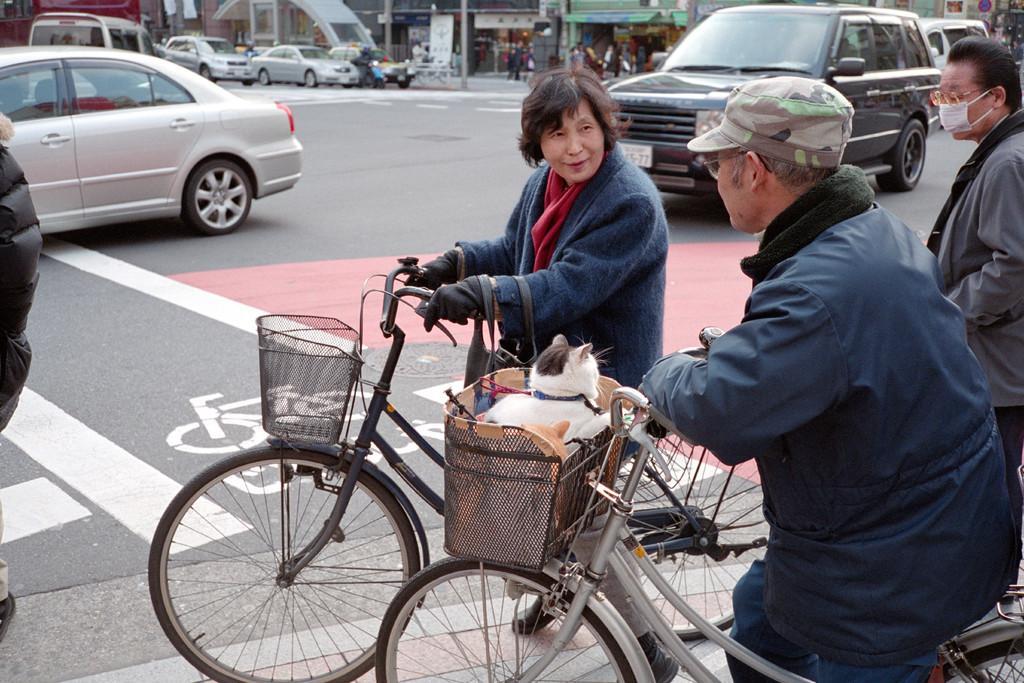In one or two sentences, can you explain what this image depicts? A person in the front wearing a hat and specs is sitting on a cycle. On the cycle there is a basket. Inside the basket there is a cat. Also a lady holding a bag and a gloves is sitting on a cycle. There is a road. On the road there are many vehicles. In the background there are buildings, vehicles, peoples. And also in the right a person wearing a mask is walking. 